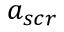<formula> <loc_0><loc_0><loc_500><loc_500>a _ { s c r }</formula> 